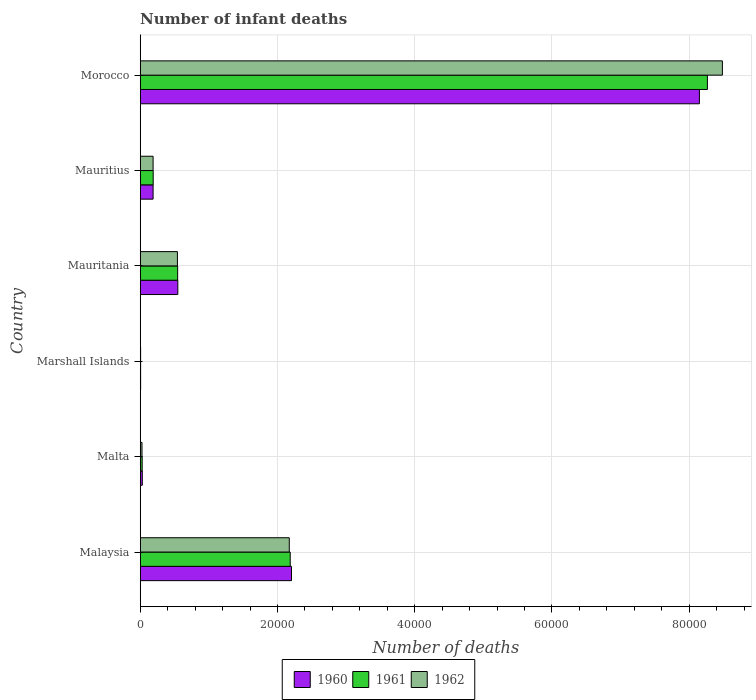Are the number of bars per tick equal to the number of legend labels?
Ensure brevity in your answer.  Yes. Are the number of bars on each tick of the Y-axis equal?
Offer a terse response. Yes. How many bars are there on the 6th tick from the bottom?
Keep it short and to the point. 3. What is the label of the 4th group of bars from the top?
Keep it short and to the point. Marshall Islands. What is the number of infant deaths in 1962 in Mauritius?
Ensure brevity in your answer.  1876. Across all countries, what is the maximum number of infant deaths in 1962?
Your answer should be very brief. 8.48e+04. Across all countries, what is the minimum number of infant deaths in 1961?
Your response must be concise. 56. In which country was the number of infant deaths in 1960 maximum?
Offer a terse response. Morocco. In which country was the number of infant deaths in 1962 minimum?
Give a very brief answer. Marshall Islands. What is the total number of infant deaths in 1962 in the graph?
Your response must be concise. 1.14e+05. What is the difference between the number of infant deaths in 1961 in Malta and that in Mauritius?
Provide a short and direct response. -1607. What is the difference between the number of infant deaths in 1961 in Marshall Islands and the number of infant deaths in 1960 in Morocco?
Make the answer very short. -8.14e+04. What is the average number of infant deaths in 1960 per country?
Ensure brevity in your answer.  1.85e+04. What is the difference between the number of infant deaths in 1960 and number of infant deaths in 1962 in Morocco?
Provide a short and direct response. -3350. In how many countries, is the number of infant deaths in 1962 greater than 52000 ?
Ensure brevity in your answer.  1. What is the ratio of the number of infant deaths in 1962 in Mauritania to that in Morocco?
Offer a terse response. 0.06. Is the difference between the number of infant deaths in 1960 in Mauritius and Morocco greater than the difference between the number of infant deaths in 1962 in Mauritius and Morocco?
Provide a succinct answer. Yes. What is the difference between the highest and the second highest number of infant deaths in 1962?
Your response must be concise. 6.31e+04. What is the difference between the highest and the lowest number of infant deaths in 1962?
Keep it short and to the point. 8.48e+04. Is the sum of the number of infant deaths in 1960 in Mauritania and Morocco greater than the maximum number of infant deaths in 1961 across all countries?
Your answer should be compact. Yes. What does the 3rd bar from the bottom in Mauritius represents?
Keep it short and to the point. 1962. How many bars are there?
Your response must be concise. 18. Are all the bars in the graph horizontal?
Offer a terse response. Yes. What is the difference between two consecutive major ticks on the X-axis?
Your answer should be very brief. 2.00e+04. Are the values on the major ticks of X-axis written in scientific E-notation?
Offer a terse response. No. How many legend labels are there?
Keep it short and to the point. 3. How are the legend labels stacked?
Your response must be concise. Horizontal. What is the title of the graph?
Offer a terse response. Number of infant deaths. Does "1974" appear as one of the legend labels in the graph?
Offer a very short reply. No. What is the label or title of the X-axis?
Offer a very short reply. Number of deaths. What is the Number of deaths in 1960 in Malaysia?
Your response must be concise. 2.20e+04. What is the Number of deaths in 1961 in Malaysia?
Provide a succinct answer. 2.19e+04. What is the Number of deaths of 1962 in Malaysia?
Your response must be concise. 2.17e+04. What is the Number of deaths in 1960 in Malta?
Offer a terse response. 301. What is the Number of deaths of 1961 in Malta?
Offer a terse response. 283. What is the Number of deaths in 1962 in Malta?
Make the answer very short. 258. What is the Number of deaths of 1960 in Marshall Islands?
Your response must be concise. 57. What is the Number of deaths of 1961 in Marshall Islands?
Give a very brief answer. 56. What is the Number of deaths in 1962 in Marshall Islands?
Keep it short and to the point. 55. What is the Number of deaths in 1960 in Mauritania?
Provide a succinct answer. 5480. What is the Number of deaths of 1961 in Mauritania?
Keep it short and to the point. 5454. What is the Number of deaths of 1962 in Mauritania?
Your response must be concise. 5420. What is the Number of deaths in 1960 in Mauritius?
Keep it short and to the point. 1875. What is the Number of deaths in 1961 in Mauritius?
Your answer should be very brief. 1890. What is the Number of deaths in 1962 in Mauritius?
Ensure brevity in your answer.  1876. What is the Number of deaths in 1960 in Morocco?
Provide a succinct answer. 8.15e+04. What is the Number of deaths in 1961 in Morocco?
Offer a very short reply. 8.27e+04. What is the Number of deaths of 1962 in Morocco?
Your answer should be compact. 8.48e+04. Across all countries, what is the maximum Number of deaths in 1960?
Give a very brief answer. 8.15e+04. Across all countries, what is the maximum Number of deaths of 1961?
Make the answer very short. 8.27e+04. Across all countries, what is the maximum Number of deaths of 1962?
Ensure brevity in your answer.  8.48e+04. Across all countries, what is the minimum Number of deaths of 1960?
Offer a terse response. 57. Across all countries, what is the minimum Number of deaths of 1962?
Offer a terse response. 55. What is the total Number of deaths of 1960 in the graph?
Offer a terse response. 1.11e+05. What is the total Number of deaths of 1961 in the graph?
Your answer should be compact. 1.12e+05. What is the total Number of deaths in 1962 in the graph?
Make the answer very short. 1.14e+05. What is the difference between the Number of deaths in 1960 in Malaysia and that in Malta?
Provide a succinct answer. 2.17e+04. What is the difference between the Number of deaths in 1961 in Malaysia and that in Malta?
Keep it short and to the point. 2.16e+04. What is the difference between the Number of deaths in 1962 in Malaysia and that in Malta?
Offer a terse response. 2.15e+04. What is the difference between the Number of deaths in 1960 in Malaysia and that in Marshall Islands?
Provide a short and direct response. 2.20e+04. What is the difference between the Number of deaths in 1961 in Malaysia and that in Marshall Islands?
Keep it short and to the point. 2.18e+04. What is the difference between the Number of deaths of 1962 in Malaysia and that in Marshall Islands?
Give a very brief answer. 2.17e+04. What is the difference between the Number of deaths of 1960 in Malaysia and that in Mauritania?
Make the answer very short. 1.66e+04. What is the difference between the Number of deaths of 1961 in Malaysia and that in Mauritania?
Your answer should be very brief. 1.64e+04. What is the difference between the Number of deaths of 1962 in Malaysia and that in Mauritania?
Make the answer very short. 1.63e+04. What is the difference between the Number of deaths in 1960 in Malaysia and that in Mauritius?
Your response must be concise. 2.02e+04. What is the difference between the Number of deaths of 1961 in Malaysia and that in Mauritius?
Provide a succinct answer. 2.00e+04. What is the difference between the Number of deaths in 1962 in Malaysia and that in Mauritius?
Your response must be concise. 1.98e+04. What is the difference between the Number of deaths in 1960 in Malaysia and that in Morocco?
Offer a terse response. -5.94e+04. What is the difference between the Number of deaths in 1961 in Malaysia and that in Morocco?
Give a very brief answer. -6.08e+04. What is the difference between the Number of deaths in 1962 in Malaysia and that in Morocco?
Your response must be concise. -6.31e+04. What is the difference between the Number of deaths in 1960 in Malta and that in Marshall Islands?
Provide a short and direct response. 244. What is the difference between the Number of deaths in 1961 in Malta and that in Marshall Islands?
Your response must be concise. 227. What is the difference between the Number of deaths in 1962 in Malta and that in Marshall Islands?
Provide a succinct answer. 203. What is the difference between the Number of deaths of 1960 in Malta and that in Mauritania?
Offer a terse response. -5179. What is the difference between the Number of deaths in 1961 in Malta and that in Mauritania?
Make the answer very short. -5171. What is the difference between the Number of deaths in 1962 in Malta and that in Mauritania?
Keep it short and to the point. -5162. What is the difference between the Number of deaths of 1960 in Malta and that in Mauritius?
Your answer should be compact. -1574. What is the difference between the Number of deaths in 1961 in Malta and that in Mauritius?
Give a very brief answer. -1607. What is the difference between the Number of deaths in 1962 in Malta and that in Mauritius?
Make the answer very short. -1618. What is the difference between the Number of deaths in 1960 in Malta and that in Morocco?
Offer a terse response. -8.12e+04. What is the difference between the Number of deaths of 1961 in Malta and that in Morocco?
Keep it short and to the point. -8.24e+04. What is the difference between the Number of deaths of 1962 in Malta and that in Morocco?
Ensure brevity in your answer.  -8.46e+04. What is the difference between the Number of deaths in 1960 in Marshall Islands and that in Mauritania?
Offer a terse response. -5423. What is the difference between the Number of deaths in 1961 in Marshall Islands and that in Mauritania?
Offer a terse response. -5398. What is the difference between the Number of deaths of 1962 in Marshall Islands and that in Mauritania?
Your answer should be very brief. -5365. What is the difference between the Number of deaths in 1960 in Marshall Islands and that in Mauritius?
Offer a very short reply. -1818. What is the difference between the Number of deaths in 1961 in Marshall Islands and that in Mauritius?
Your response must be concise. -1834. What is the difference between the Number of deaths in 1962 in Marshall Islands and that in Mauritius?
Offer a very short reply. -1821. What is the difference between the Number of deaths in 1960 in Marshall Islands and that in Morocco?
Your response must be concise. -8.14e+04. What is the difference between the Number of deaths in 1961 in Marshall Islands and that in Morocco?
Make the answer very short. -8.26e+04. What is the difference between the Number of deaths of 1962 in Marshall Islands and that in Morocco?
Your answer should be compact. -8.48e+04. What is the difference between the Number of deaths in 1960 in Mauritania and that in Mauritius?
Keep it short and to the point. 3605. What is the difference between the Number of deaths in 1961 in Mauritania and that in Mauritius?
Your answer should be very brief. 3564. What is the difference between the Number of deaths of 1962 in Mauritania and that in Mauritius?
Provide a succinct answer. 3544. What is the difference between the Number of deaths in 1960 in Mauritania and that in Morocco?
Offer a terse response. -7.60e+04. What is the difference between the Number of deaths in 1961 in Mauritania and that in Morocco?
Ensure brevity in your answer.  -7.72e+04. What is the difference between the Number of deaths of 1962 in Mauritania and that in Morocco?
Give a very brief answer. -7.94e+04. What is the difference between the Number of deaths in 1960 in Mauritius and that in Morocco?
Your answer should be very brief. -7.96e+04. What is the difference between the Number of deaths of 1961 in Mauritius and that in Morocco?
Make the answer very short. -8.08e+04. What is the difference between the Number of deaths of 1962 in Mauritius and that in Morocco?
Your answer should be very brief. -8.30e+04. What is the difference between the Number of deaths of 1960 in Malaysia and the Number of deaths of 1961 in Malta?
Offer a terse response. 2.18e+04. What is the difference between the Number of deaths in 1960 in Malaysia and the Number of deaths in 1962 in Malta?
Keep it short and to the point. 2.18e+04. What is the difference between the Number of deaths in 1961 in Malaysia and the Number of deaths in 1962 in Malta?
Your response must be concise. 2.16e+04. What is the difference between the Number of deaths in 1960 in Malaysia and the Number of deaths in 1961 in Marshall Islands?
Ensure brevity in your answer.  2.20e+04. What is the difference between the Number of deaths in 1960 in Malaysia and the Number of deaths in 1962 in Marshall Islands?
Offer a very short reply. 2.20e+04. What is the difference between the Number of deaths in 1961 in Malaysia and the Number of deaths in 1962 in Marshall Islands?
Keep it short and to the point. 2.18e+04. What is the difference between the Number of deaths in 1960 in Malaysia and the Number of deaths in 1961 in Mauritania?
Make the answer very short. 1.66e+04. What is the difference between the Number of deaths in 1960 in Malaysia and the Number of deaths in 1962 in Mauritania?
Your answer should be very brief. 1.66e+04. What is the difference between the Number of deaths in 1961 in Malaysia and the Number of deaths in 1962 in Mauritania?
Give a very brief answer. 1.64e+04. What is the difference between the Number of deaths of 1960 in Malaysia and the Number of deaths of 1961 in Mauritius?
Offer a very short reply. 2.02e+04. What is the difference between the Number of deaths of 1960 in Malaysia and the Number of deaths of 1962 in Mauritius?
Your response must be concise. 2.02e+04. What is the difference between the Number of deaths of 1961 in Malaysia and the Number of deaths of 1962 in Mauritius?
Provide a succinct answer. 2.00e+04. What is the difference between the Number of deaths of 1960 in Malaysia and the Number of deaths of 1961 in Morocco?
Your answer should be very brief. -6.06e+04. What is the difference between the Number of deaths of 1960 in Malaysia and the Number of deaths of 1962 in Morocco?
Provide a succinct answer. -6.28e+04. What is the difference between the Number of deaths of 1961 in Malaysia and the Number of deaths of 1962 in Morocco?
Provide a short and direct response. -6.30e+04. What is the difference between the Number of deaths in 1960 in Malta and the Number of deaths in 1961 in Marshall Islands?
Your response must be concise. 245. What is the difference between the Number of deaths in 1960 in Malta and the Number of deaths in 1962 in Marshall Islands?
Your answer should be very brief. 246. What is the difference between the Number of deaths of 1961 in Malta and the Number of deaths of 1962 in Marshall Islands?
Your answer should be very brief. 228. What is the difference between the Number of deaths of 1960 in Malta and the Number of deaths of 1961 in Mauritania?
Ensure brevity in your answer.  -5153. What is the difference between the Number of deaths in 1960 in Malta and the Number of deaths in 1962 in Mauritania?
Offer a terse response. -5119. What is the difference between the Number of deaths in 1961 in Malta and the Number of deaths in 1962 in Mauritania?
Provide a short and direct response. -5137. What is the difference between the Number of deaths in 1960 in Malta and the Number of deaths in 1961 in Mauritius?
Provide a succinct answer. -1589. What is the difference between the Number of deaths in 1960 in Malta and the Number of deaths in 1962 in Mauritius?
Keep it short and to the point. -1575. What is the difference between the Number of deaths in 1961 in Malta and the Number of deaths in 1962 in Mauritius?
Provide a short and direct response. -1593. What is the difference between the Number of deaths in 1960 in Malta and the Number of deaths in 1961 in Morocco?
Offer a very short reply. -8.24e+04. What is the difference between the Number of deaths in 1960 in Malta and the Number of deaths in 1962 in Morocco?
Your answer should be very brief. -8.45e+04. What is the difference between the Number of deaths of 1961 in Malta and the Number of deaths of 1962 in Morocco?
Your response must be concise. -8.46e+04. What is the difference between the Number of deaths in 1960 in Marshall Islands and the Number of deaths in 1961 in Mauritania?
Keep it short and to the point. -5397. What is the difference between the Number of deaths of 1960 in Marshall Islands and the Number of deaths of 1962 in Mauritania?
Offer a terse response. -5363. What is the difference between the Number of deaths of 1961 in Marshall Islands and the Number of deaths of 1962 in Mauritania?
Offer a very short reply. -5364. What is the difference between the Number of deaths in 1960 in Marshall Islands and the Number of deaths in 1961 in Mauritius?
Provide a short and direct response. -1833. What is the difference between the Number of deaths in 1960 in Marshall Islands and the Number of deaths in 1962 in Mauritius?
Your answer should be compact. -1819. What is the difference between the Number of deaths of 1961 in Marshall Islands and the Number of deaths of 1962 in Mauritius?
Give a very brief answer. -1820. What is the difference between the Number of deaths of 1960 in Marshall Islands and the Number of deaths of 1961 in Morocco?
Your response must be concise. -8.26e+04. What is the difference between the Number of deaths in 1960 in Marshall Islands and the Number of deaths in 1962 in Morocco?
Offer a very short reply. -8.48e+04. What is the difference between the Number of deaths of 1961 in Marshall Islands and the Number of deaths of 1962 in Morocco?
Give a very brief answer. -8.48e+04. What is the difference between the Number of deaths in 1960 in Mauritania and the Number of deaths in 1961 in Mauritius?
Provide a short and direct response. 3590. What is the difference between the Number of deaths of 1960 in Mauritania and the Number of deaths of 1962 in Mauritius?
Ensure brevity in your answer.  3604. What is the difference between the Number of deaths of 1961 in Mauritania and the Number of deaths of 1962 in Mauritius?
Ensure brevity in your answer.  3578. What is the difference between the Number of deaths of 1960 in Mauritania and the Number of deaths of 1961 in Morocco?
Provide a short and direct response. -7.72e+04. What is the difference between the Number of deaths in 1960 in Mauritania and the Number of deaths in 1962 in Morocco?
Make the answer very short. -7.94e+04. What is the difference between the Number of deaths in 1961 in Mauritania and the Number of deaths in 1962 in Morocco?
Provide a short and direct response. -7.94e+04. What is the difference between the Number of deaths of 1960 in Mauritius and the Number of deaths of 1961 in Morocco?
Your response must be concise. -8.08e+04. What is the difference between the Number of deaths in 1960 in Mauritius and the Number of deaths in 1962 in Morocco?
Keep it short and to the point. -8.30e+04. What is the difference between the Number of deaths in 1961 in Mauritius and the Number of deaths in 1962 in Morocco?
Your response must be concise. -8.30e+04. What is the average Number of deaths in 1960 per country?
Give a very brief answer. 1.85e+04. What is the average Number of deaths of 1961 per country?
Offer a very short reply. 1.87e+04. What is the average Number of deaths in 1962 per country?
Ensure brevity in your answer.  1.90e+04. What is the difference between the Number of deaths of 1960 and Number of deaths of 1961 in Malaysia?
Provide a succinct answer. 186. What is the difference between the Number of deaths of 1960 and Number of deaths of 1962 in Malaysia?
Make the answer very short. 323. What is the difference between the Number of deaths of 1961 and Number of deaths of 1962 in Malaysia?
Your answer should be compact. 137. What is the difference between the Number of deaths in 1960 and Number of deaths in 1961 in Marshall Islands?
Your answer should be very brief. 1. What is the difference between the Number of deaths of 1960 and Number of deaths of 1962 in Marshall Islands?
Offer a terse response. 2. What is the difference between the Number of deaths of 1961 and Number of deaths of 1962 in Marshall Islands?
Make the answer very short. 1. What is the difference between the Number of deaths of 1960 and Number of deaths of 1961 in Mauritania?
Keep it short and to the point. 26. What is the difference between the Number of deaths in 1960 and Number of deaths in 1961 in Mauritius?
Your answer should be compact. -15. What is the difference between the Number of deaths in 1960 and Number of deaths in 1962 in Mauritius?
Your answer should be compact. -1. What is the difference between the Number of deaths in 1960 and Number of deaths in 1961 in Morocco?
Your answer should be very brief. -1166. What is the difference between the Number of deaths in 1960 and Number of deaths in 1962 in Morocco?
Keep it short and to the point. -3350. What is the difference between the Number of deaths of 1961 and Number of deaths of 1962 in Morocco?
Ensure brevity in your answer.  -2184. What is the ratio of the Number of deaths of 1960 in Malaysia to that in Malta?
Provide a succinct answer. 73.24. What is the ratio of the Number of deaths in 1961 in Malaysia to that in Malta?
Your answer should be compact. 77.24. What is the ratio of the Number of deaths of 1962 in Malaysia to that in Malta?
Provide a short and direct response. 84.2. What is the ratio of the Number of deaths in 1960 in Malaysia to that in Marshall Islands?
Keep it short and to the point. 386.77. What is the ratio of the Number of deaths in 1961 in Malaysia to that in Marshall Islands?
Make the answer very short. 390.36. What is the ratio of the Number of deaths in 1962 in Malaysia to that in Marshall Islands?
Offer a very short reply. 394.96. What is the ratio of the Number of deaths of 1960 in Malaysia to that in Mauritania?
Offer a very short reply. 4.02. What is the ratio of the Number of deaths in 1961 in Malaysia to that in Mauritania?
Keep it short and to the point. 4.01. What is the ratio of the Number of deaths in 1962 in Malaysia to that in Mauritania?
Provide a short and direct response. 4.01. What is the ratio of the Number of deaths in 1960 in Malaysia to that in Mauritius?
Give a very brief answer. 11.76. What is the ratio of the Number of deaths in 1961 in Malaysia to that in Mauritius?
Offer a very short reply. 11.57. What is the ratio of the Number of deaths in 1962 in Malaysia to that in Mauritius?
Your answer should be compact. 11.58. What is the ratio of the Number of deaths of 1960 in Malaysia to that in Morocco?
Your answer should be compact. 0.27. What is the ratio of the Number of deaths in 1961 in Malaysia to that in Morocco?
Keep it short and to the point. 0.26. What is the ratio of the Number of deaths of 1962 in Malaysia to that in Morocco?
Your answer should be very brief. 0.26. What is the ratio of the Number of deaths in 1960 in Malta to that in Marshall Islands?
Offer a terse response. 5.28. What is the ratio of the Number of deaths in 1961 in Malta to that in Marshall Islands?
Offer a very short reply. 5.05. What is the ratio of the Number of deaths in 1962 in Malta to that in Marshall Islands?
Ensure brevity in your answer.  4.69. What is the ratio of the Number of deaths of 1960 in Malta to that in Mauritania?
Your answer should be compact. 0.05. What is the ratio of the Number of deaths of 1961 in Malta to that in Mauritania?
Your answer should be compact. 0.05. What is the ratio of the Number of deaths of 1962 in Malta to that in Mauritania?
Keep it short and to the point. 0.05. What is the ratio of the Number of deaths in 1960 in Malta to that in Mauritius?
Provide a short and direct response. 0.16. What is the ratio of the Number of deaths in 1961 in Malta to that in Mauritius?
Ensure brevity in your answer.  0.15. What is the ratio of the Number of deaths of 1962 in Malta to that in Mauritius?
Keep it short and to the point. 0.14. What is the ratio of the Number of deaths of 1960 in Malta to that in Morocco?
Ensure brevity in your answer.  0. What is the ratio of the Number of deaths in 1961 in Malta to that in Morocco?
Offer a very short reply. 0. What is the ratio of the Number of deaths in 1962 in Malta to that in Morocco?
Offer a terse response. 0. What is the ratio of the Number of deaths of 1960 in Marshall Islands to that in Mauritania?
Make the answer very short. 0.01. What is the ratio of the Number of deaths of 1961 in Marshall Islands to that in Mauritania?
Keep it short and to the point. 0.01. What is the ratio of the Number of deaths of 1962 in Marshall Islands to that in Mauritania?
Provide a succinct answer. 0.01. What is the ratio of the Number of deaths in 1960 in Marshall Islands to that in Mauritius?
Offer a terse response. 0.03. What is the ratio of the Number of deaths of 1961 in Marshall Islands to that in Mauritius?
Your response must be concise. 0.03. What is the ratio of the Number of deaths of 1962 in Marshall Islands to that in Mauritius?
Offer a very short reply. 0.03. What is the ratio of the Number of deaths of 1960 in Marshall Islands to that in Morocco?
Your answer should be very brief. 0. What is the ratio of the Number of deaths in 1961 in Marshall Islands to that in Morocco?
Keep it short and to the point. 0. What is the ratio of the Number of deaths of 1962 in Marshall Islands to that in Morocco?
Your response must be concise. 0. What is the ratio of the Number of deaths in 1960 in Mauritania to that in Mauritius?
Provide a short and direct response. 2.92. What is the ratio of the Number of deaths of 1961 in Mauritania to that in Mauritius?
Provide a succinct answer. 2.89. What is the ratio of the Number of deaths of 1962 in Mauritania to that in Mauritius?
Offer a very short reply. 2.89. What is the ratio of the Number of deaths of 1960 in Mauritania to that in Morocco?
Your answer should be very brief. 0.07. What is the ratio of the Number of deaths of 1961 in Mauritania to that in Morocco?
Offer a terse response. 0.07. What is the ratio of the Number of deaths of 1962 in Mauritania to that in Morocco?
Keep it short and to the point. 0.06. What is the ratio of the Number of deaths of 1960 in Mauritius to that in Morocco?
Provide a short and direct response. 0.02. What is the ratio of the Number of deaths in 1961 in Mauritius to that in Morocco?
Offer a very short reply. 0.02. What is the ratio of the Number of deaths of 1962 in Mauritius to that in Morocco?
Ensure brevity in your answer.  0.02. What is the difference between the highest and the second highest Number of deaths in 1960?
Keep it short and to the point. 5.94e+04. What is the difference between the highest and the second highest Number of deaths in 1961?
Provide a succinct answer. 6.08e+04. What is the difference between the highest and the second highest Number of deaths of 1962?
Give a very brief answer. 6.31e+04. What is the difference between the highest and the lowest Number of deaths in 1960?
Your answer should be compact. 8.14e+04. What is the difference between the highest and the lowest Number of deaths of 1961?
Make the answer very short. 8.26e+04. What is the difference between the highest and the lowest Number of deaths of 1962?
Offer a very short reply. 8.48e+04. 